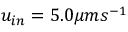<formula> <loc_0><loc_0><loc_500><loc_500>u _ { i n } = 5 . 0 \mu m s ^ { - 1 }</formula> 